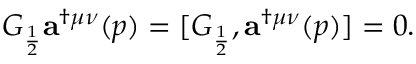Convert formula to latex. <formula><loc_0><loc_0><loc_500><loc_500>G _ { \frac { 1 } { 2 } } { a } ^ { \dag \mu \nu } ( p ) = [ G _ { \frac { 1 } { 2 } } , { a } ^ { \dag \mu \nu } ( p ) ] = 0 .</formula> 